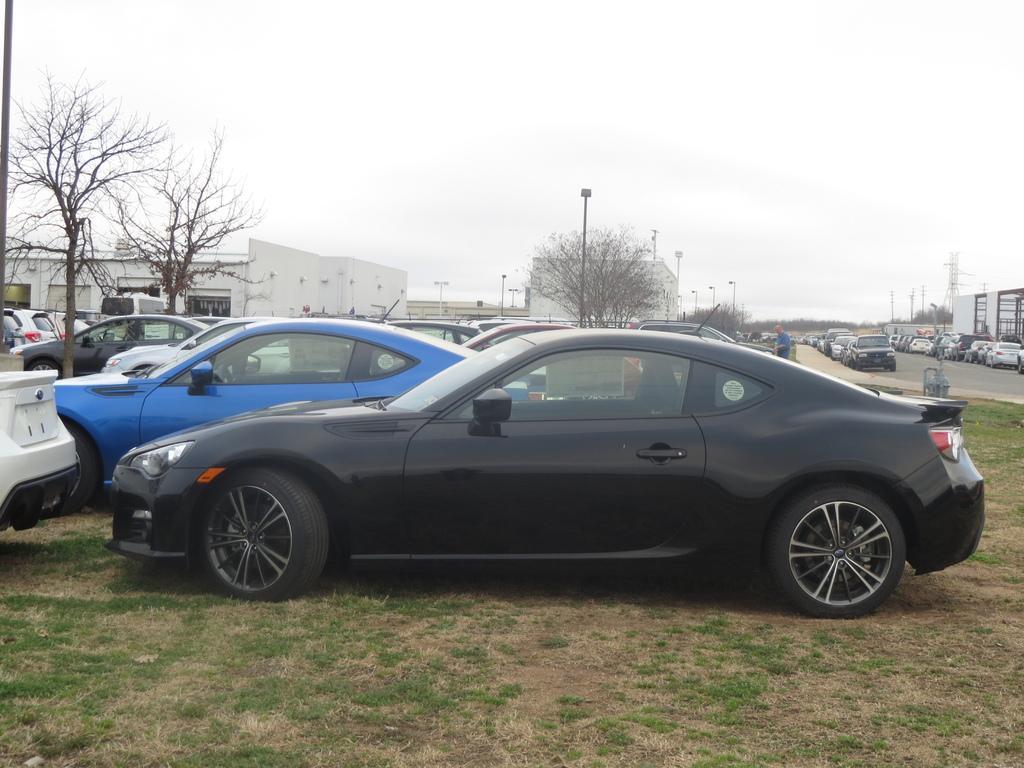Please provide a concise description of this image. In this image there are cars parked in a parking area, beside that there is a road, in the background there are trees, houses and a sky. 